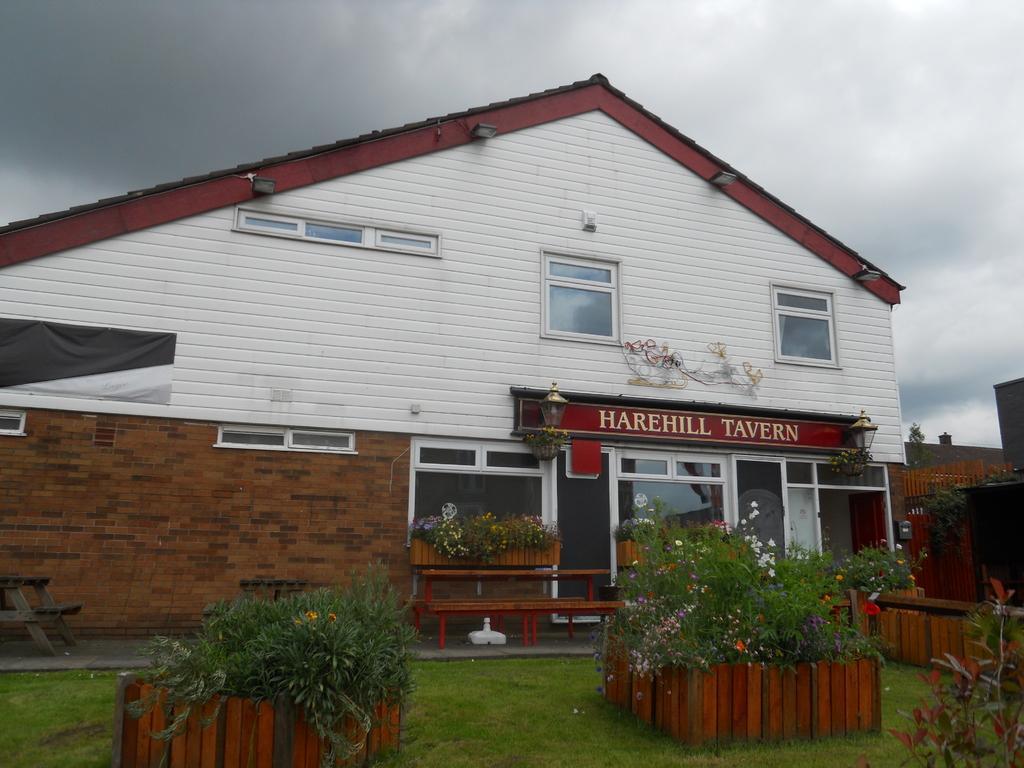Could you give a brief overview of what you see in this image? This is the front view of a building there is a glass entrance door to the building, in front of the building there is grass on the surface and there are a few plants with flowers. 